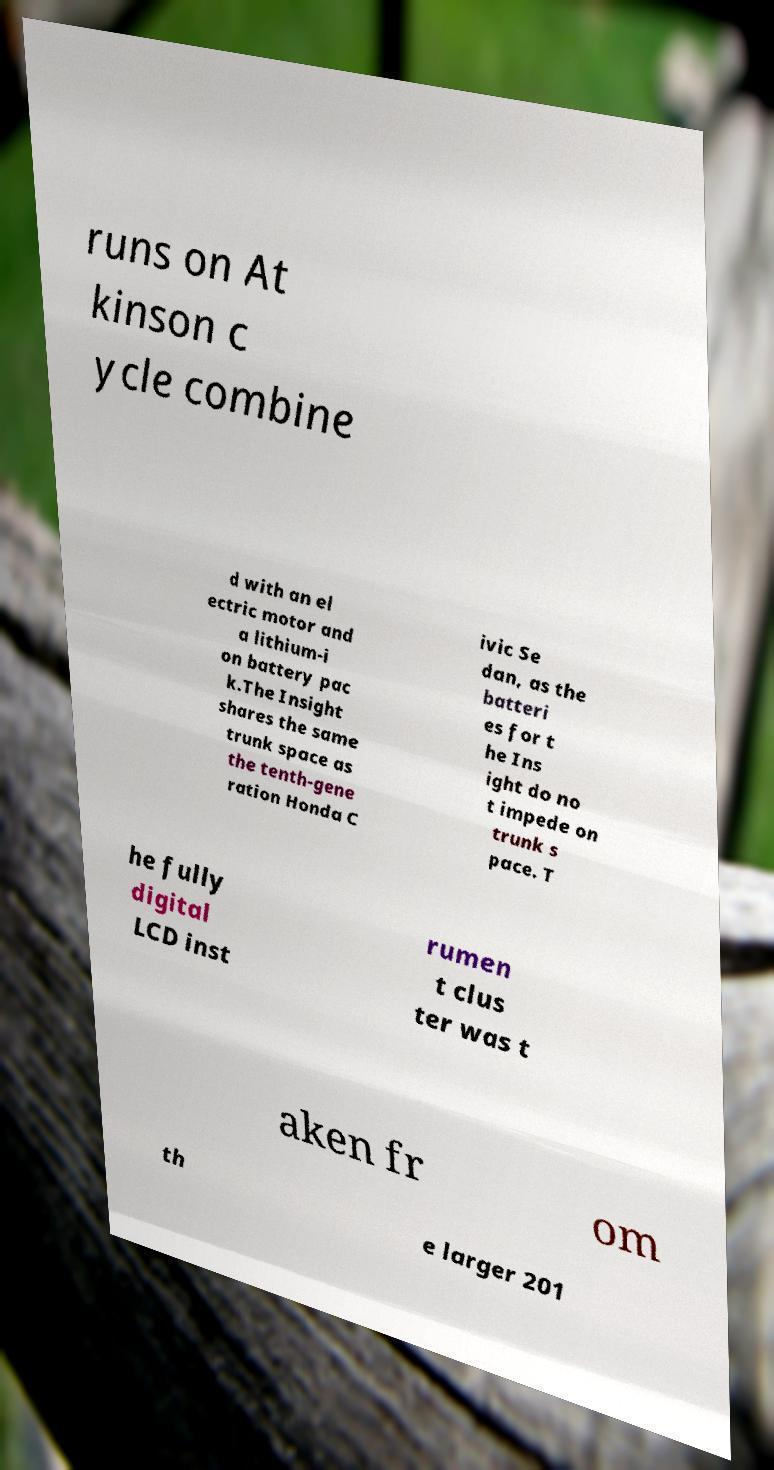Can you read and provide the text displayed in the image?This photo seems to have some interesting text. Can you extract and type it out for me? runs on At kinson c ycle combine d with an el ectric motor and a lithium-i on battery pac k.The Insight shares the same trunk space as the tenth-gene ration Honda C ivic Se dan, as the batteri es for t he Ins ight do no t impede on trunk s pace. T he fully digital LCD inst rumen t clus ter was t aken fr om th e larger 201 